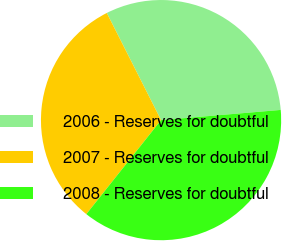Convert chart to OTSL. <chart><loc_0><loc_0><loc_500><loc_500><pie_chart><fcel>2006 - Reserves for doubtful<fcel>2007 - Reserves for doubtful<fcel>2008 - Reserves for doubtful<nl><fcel>31.11%<fcel>31.85%<fcel>37.04%<nl></chart> 